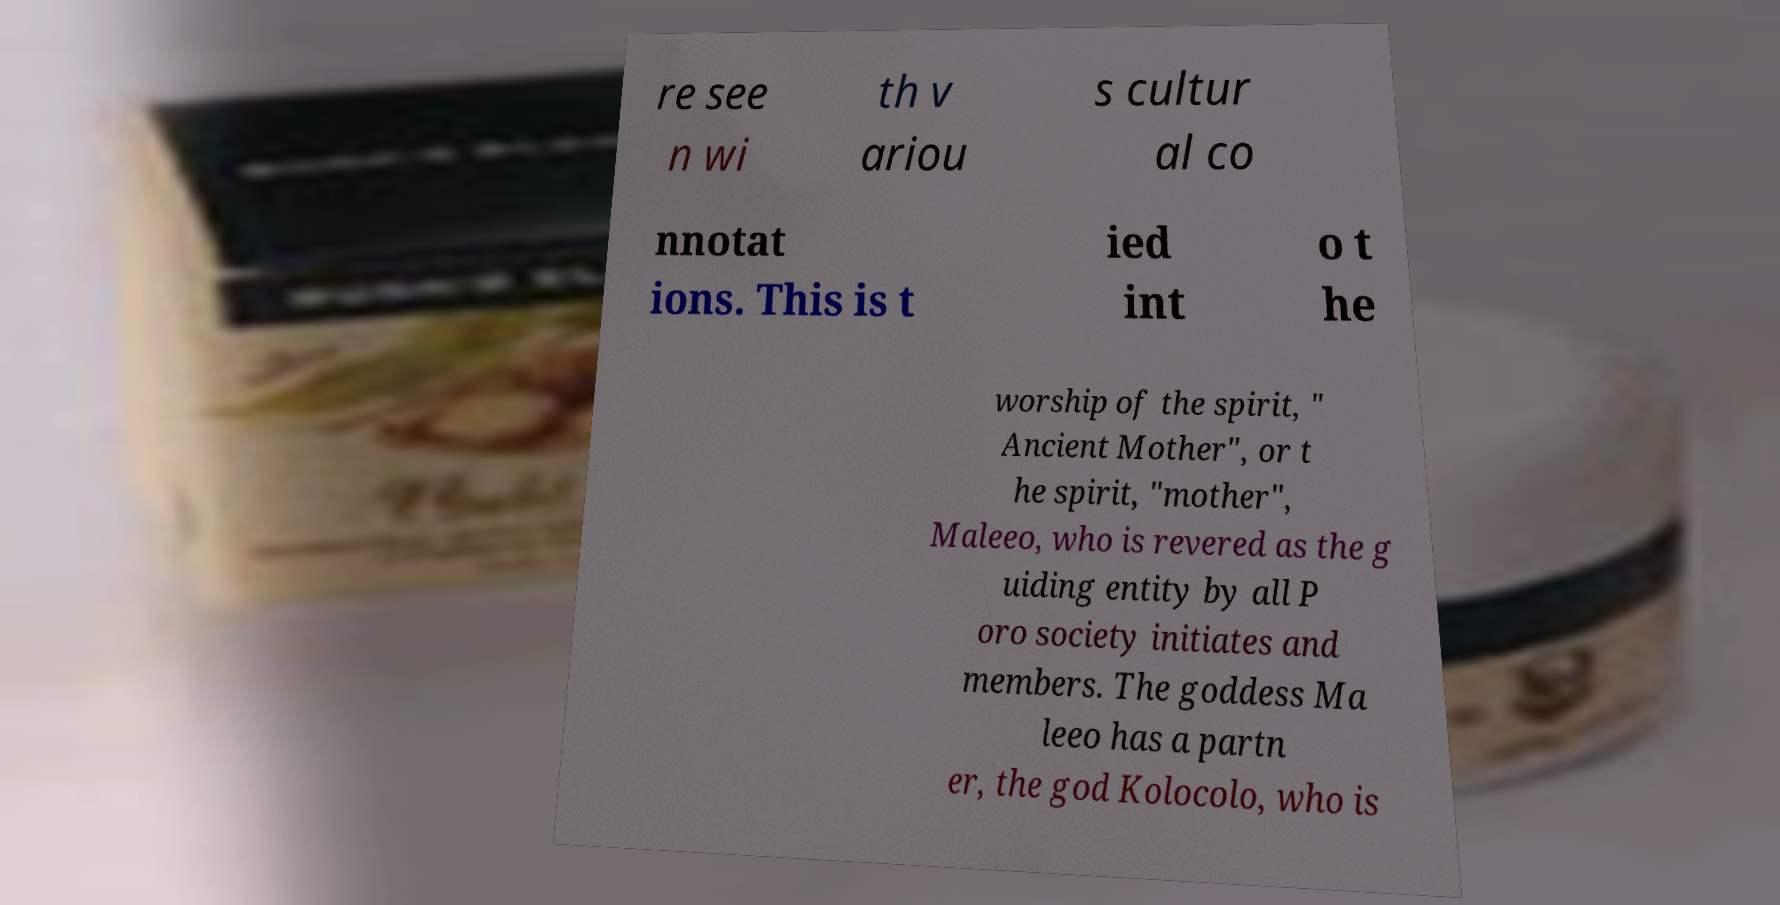Could you assist in decoding the text presented in this image and type it out clearly? re see n wi th v ariou s cultur al co nnotat ions. This is t ied int o t he worship of the spirit, " Ancient Mother", or t he spirit, "mother", Maleeo, who is revered as the g uiding entity by all P oro society initiates and members. The goddess Ma leeo has a partn er, the god Kolocolo, who is 